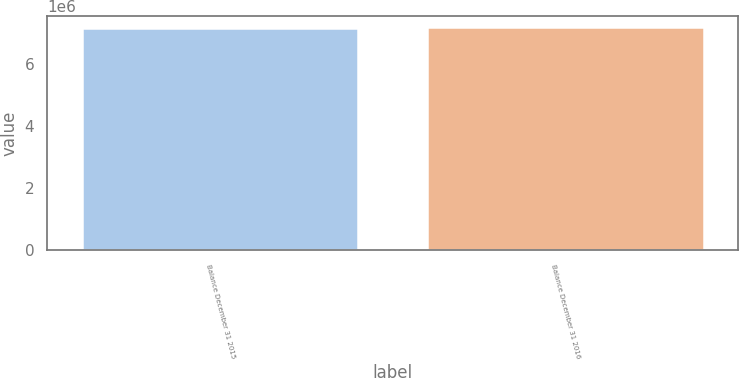Convert chart to OTSL. <chart><loc_0><loc_0><loc_500><loc_500><bar_chart><fcel>Balance December 31 2015<fcel>Balance December 31 2016<nl><fcel>7.1405e+06<fcel>7.16087e+06<nl></chart> 